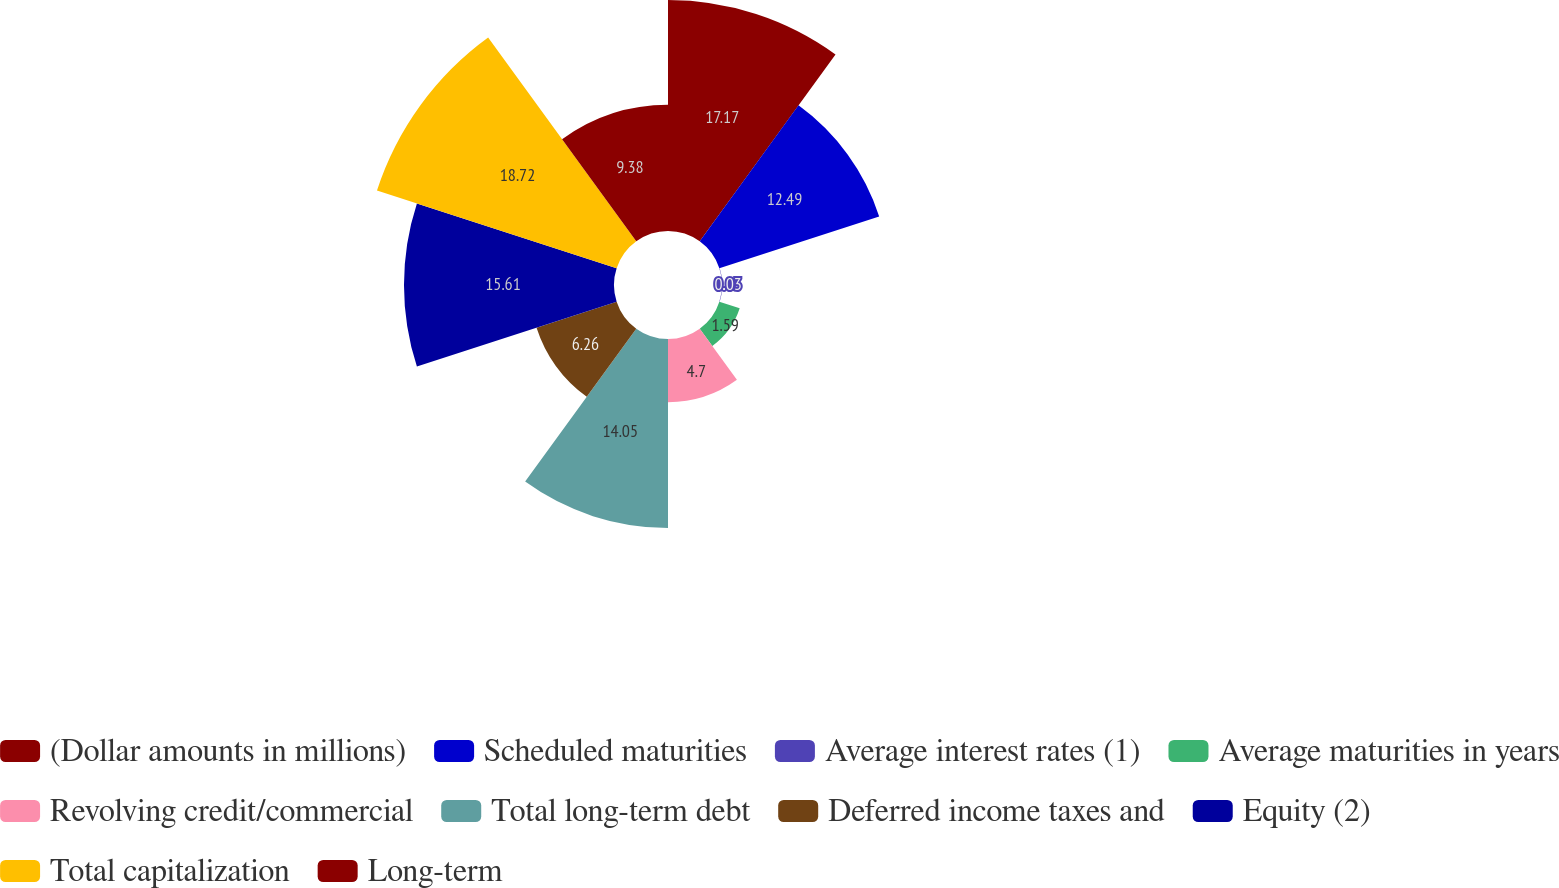<chart> <loc_0><loc_0><loc_500><loc_500><pie_chart><fcel>(Dollar amounts in millions)<fcel>Scheduled maturities<fcel>Average interest rates (1)<fcel>Average maturities in years<fcel>Revolving credit/commercial<fcel>Total long-term debt<fcel>Deferred income taxes and<fcel>Equity (2)<fcel>Total capitalization<fcel>Long-term<nl><fcel>17.17%<fcel>12.49%<fcel>0.03%<fcel>1.59%<fcel>4.7%<fcel>14.05%<fcel>6.26%<fcel>15.61%<fcel>18.73%<fcel>9.38%<nl></chart> 